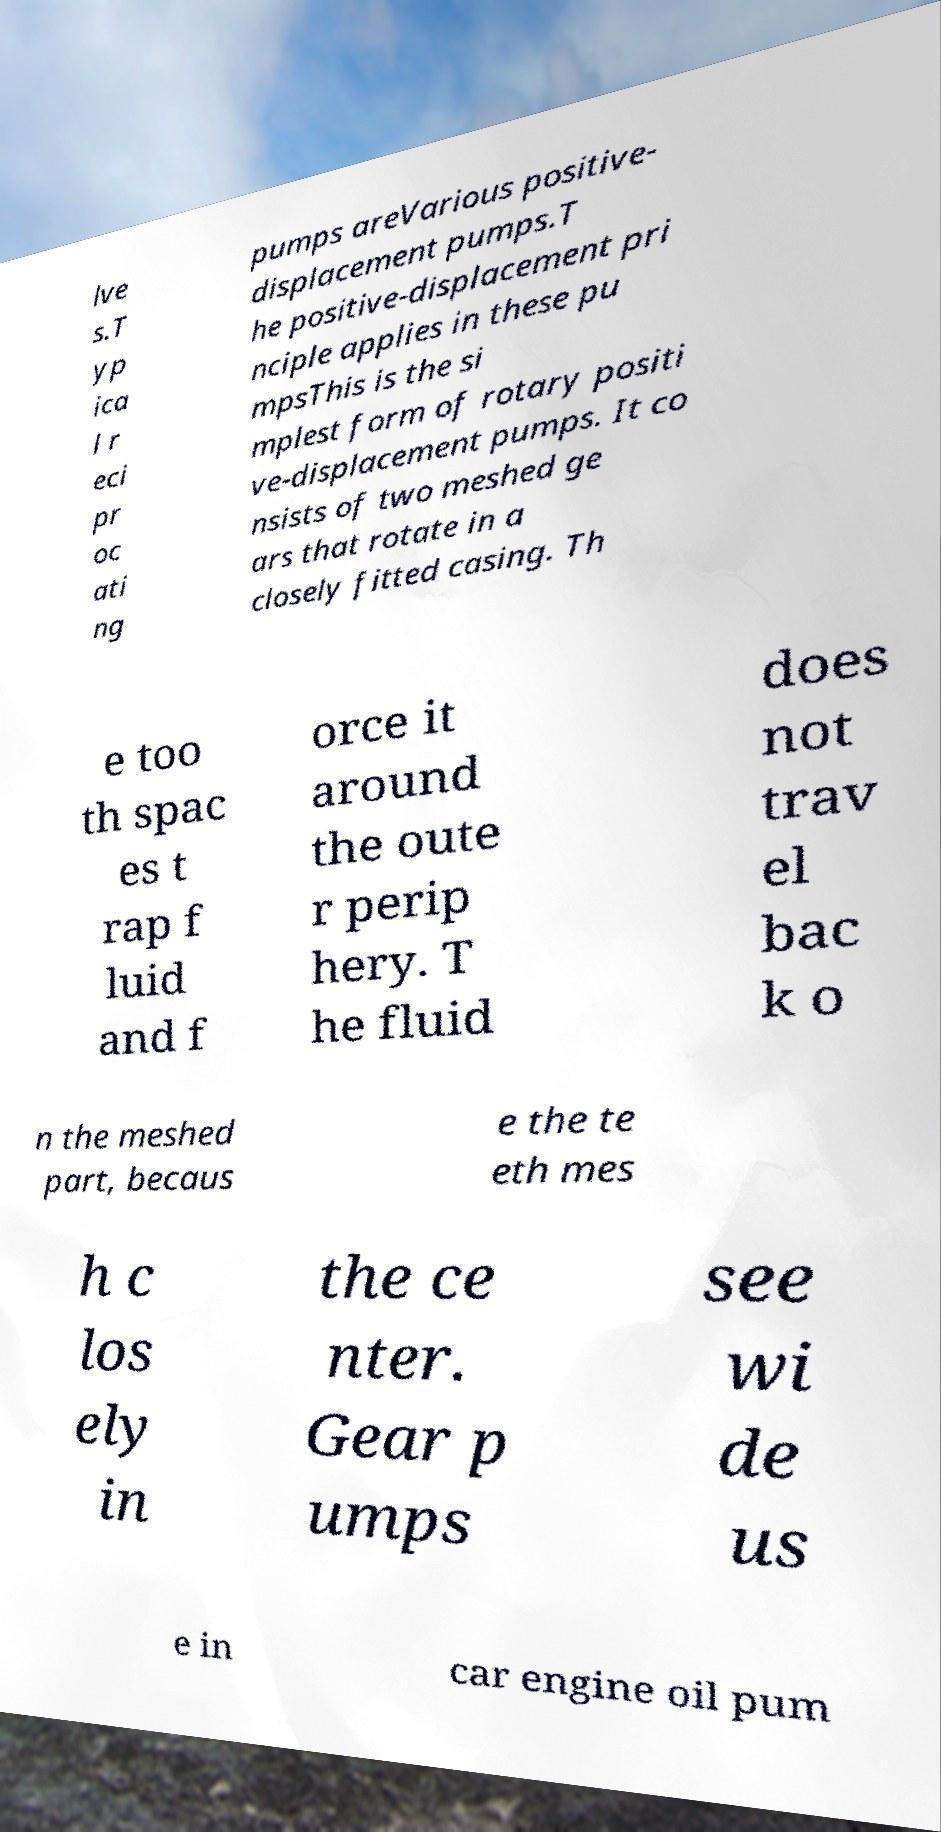What messages or text are displayed in this image? I need them in a readable, typed format. lve s.T yp ica l r eci pr oc ati ng pumps areVarious positive- displacement pumps.T he positive-displacement pri nciple applies in these pu mpsThis is the si mplest form of rotary positi ve-displacement pumps. It co nsists of two meshed ge ars that rotate in a closely fitted casing. Th e too th spac es t rap f luid and f orce it around the oute r perip hery. T he fluid does not trav el bac k o n the meshed part, becaus e the te eth mes h c los ely in the ce nter. Gear p umps see wi de us e in car engine oil pum 